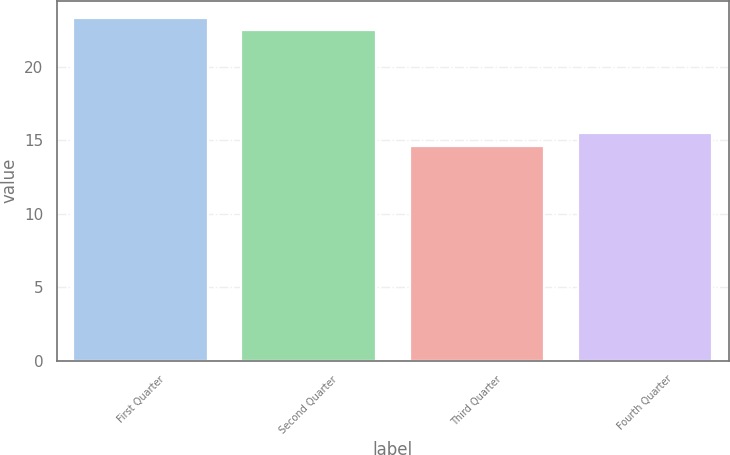Convert chart. <chart><loc_0><loc_0><loc_500><loc_500><bar_chart><fcel>First Quarter<fcel>Second Quarter<fcel>Third Quarter<fcel>Fourth Quarter<nl><fcel>23.32<fcel>22.48<fcel>14.61<fcel>15.47<nl></chart> 